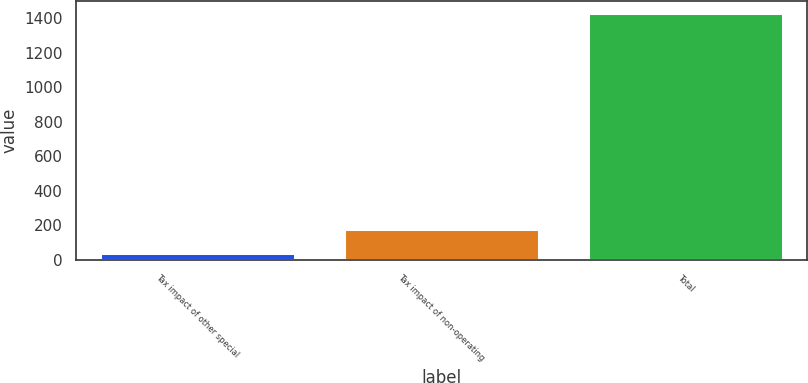Convert chart. <chart><loc_0><loc_0><loc_500><loc_500><bar_chart><fcel>Tax impact of other special<fcel>Tax impact of non-operating<fcel>Total<nl><fcel>41<fcel>179.9<fcel>1430<nl></chart> 